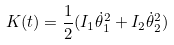Convert formula to latex. <formula><loc_0><loc_0><loc_500><loc_500>K ( t ) = \frac { 1 } { 2 } ( I _ { 1 } \dot { \theta } _ { 1 } ^ { 2 } + I _ { 2 } \dot { \theta } _ { 2 } ^ { 2 } )</formula> 